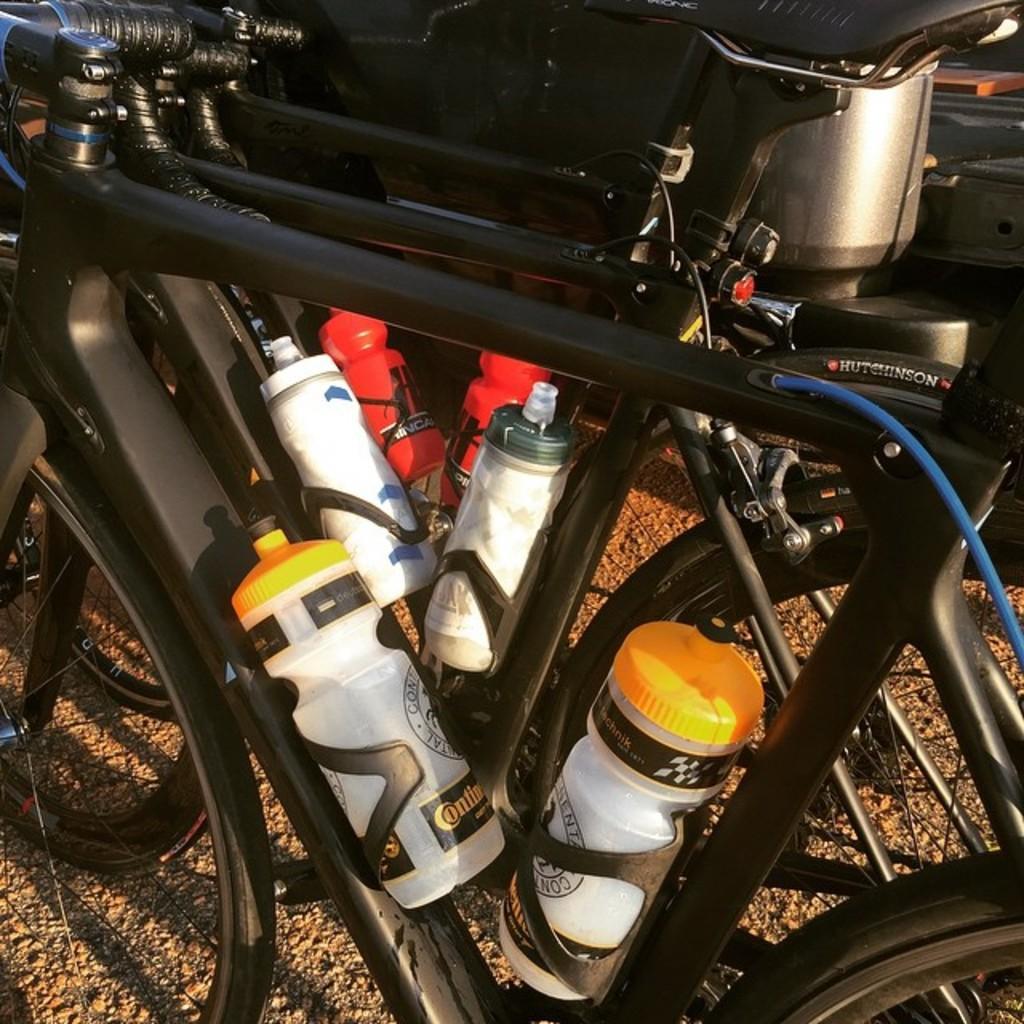In one or two sentences, can you explain what this image depicts? In this image we can see a group of bicycles placed on the ground containing some bottles. On the backside we can see a steel device. 